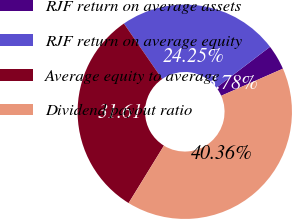Convert chart. <chart><loc_0><loc_0><loc_500><loc_500><pie_chart><fcel>RJF return on average assets<fcel>RJF return on average equity<fcel>Average equity to average<fcel>Dividend payout ratio<nl><fcel>3.78%<fcel>24.25%<fcel>31.61%<fcel>40.36%<nl></chart> 